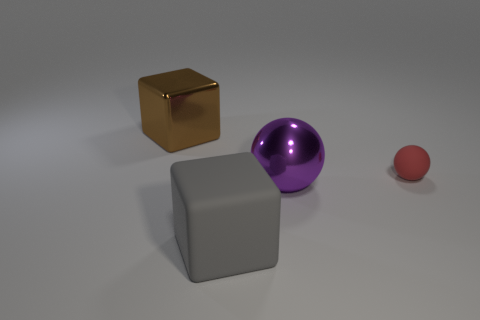Add 1 matte cylinders. How many objects exist? 5 Subtract all brown cubes. How many cubes are left? 1 Subtract all blue cylinders. How many red balls are left? 1 Add 4 small green metallic cylinders. How many small green metallic cylinders exist? 4 Subtract 0 purple cylinders. How many objects are left? 4 Subtract 1 balls. How many balls are left? 1 Subtract all green cubes. Subtract all red cylinders. How many cubes are left? 2 Subtract all blue objects. Subtract all gray matte objects. How many objects are left? 3 Add 1 shiny things. How many shiny things are left? 3 